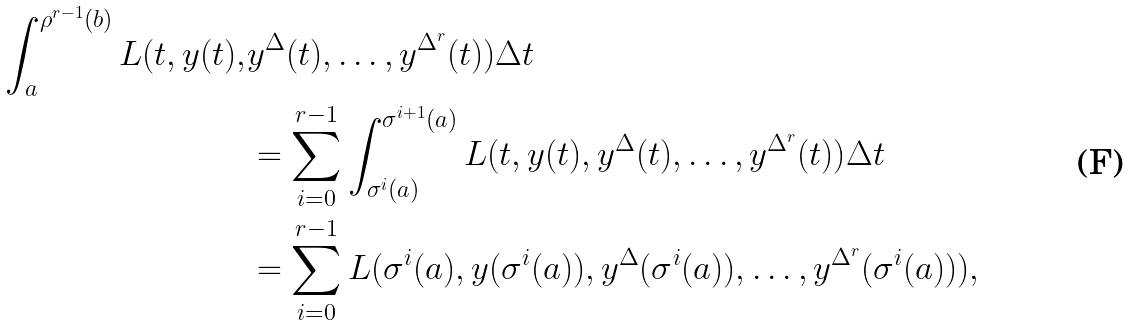Convert formula to latex. <formula><loc_0><loc_0><loc_500><loc_500>\int _ { a } ^ { \rho ^ { r - 1 } ( b ) } L ( t , y ( t ) , & y ^ { \Delta } ( t ) , \dots , y ^ { \Delta ^ { r } } ( t ) ) \Delta t \\ & = \sum _ { i = 0 } ^ { r - 1 } \int _ { \sigma ^ { i } ( a ) } ^ { \sigma ^ { i + 1 } ( a ) } L ( t , y ( t ) , y ^ { \Delta } ( t ) , \dots , y ^ { \Delta ^ { r } } ( t ) ) \Delta t \\ & = \sum _ { i = 0 } ^ { r - 1 } L ( \sigma ^ { i } ( a ) , y ( \sigma ^ { i } ( a ) ) , y ^ { \Delta } ( \sigma ^ { i } ( a ) ) , \dots , y ^ { \Delta ^ { r } } ( \sigma ^ { i } ( a ) ) ) ,</formula> 